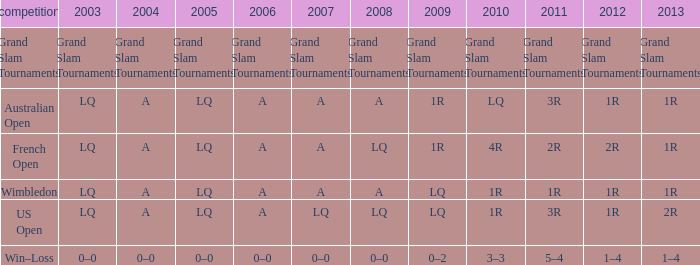Which tournament has a 2013 of 1r, and a 2012 of 1r? Australian Open, Wimbledon. 